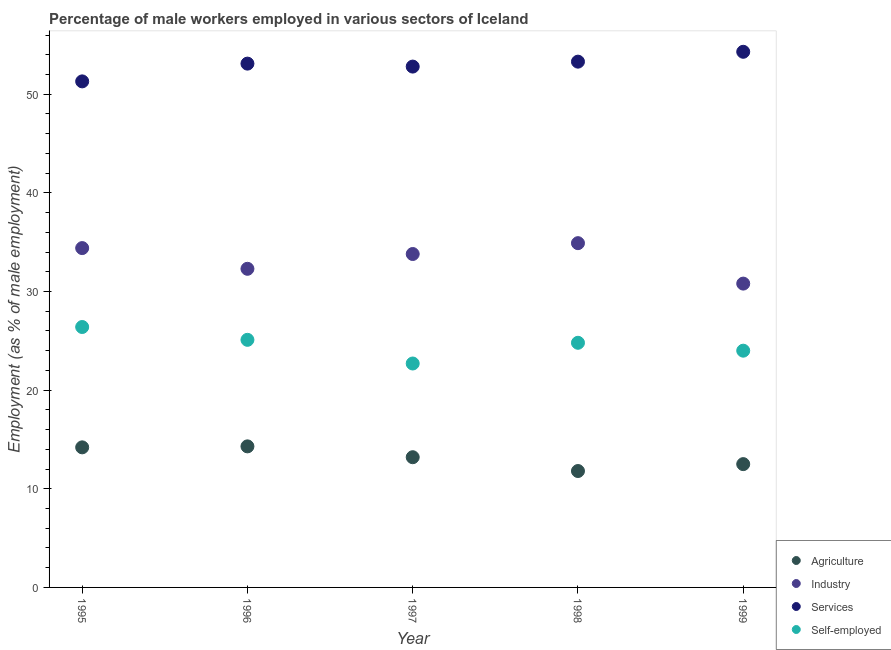How many different coloured dotlines are there?
Offer a very short reply. 4. Is the number of dotlines equal to the number of legend labels?
Give a very brief answer. Yes. What is the percentage of male workers in services in 1998?
Your answer should be compact. 53.3. Across all years, what is the maximum percentage of self employed male workers?
Offer a terse response. 26.4. Across all years, what is the minimum percentage of male workers in industry?
Provide a short and direct response. 30.8. In which year was the percentage of male workers in industry maximum?
Provide a succinct answer. 1998. What is the total percentage of self employed male workers in the graph?
Offer a very short reply. 123. What is the difference between the percentage of male workers in industry in 1995 and that in 1997?
Your answer should be compact. 0.6. What is the difference between the percentage of self employed male workers in 1999 and the percentage of male workers in agriculture in 1996?
Ensure brevity in your answer.  9.7. What is the average percentage of male workers in agriculture per year?
Offer a terse response. 13.2. In the year 1998, what is the difference between the percentage of self employed male workers and percentage of male workers in services?
Give a very brief answer. -28.5. In how many years, is the percentage of male workers in services greater than 44 %?
Your response must be concise. 5. What is the ratio of the percentage of male workers in services in 1995 to that in 1997?
Provide a short and direct response. 0.97. Is the percentage of self employed male workers in 1995 less than that in 1998?
Offer a terse response. No. What is the difference between the highest and the second highest percentage of male workers in services?
Keep it short and to the point. 1. What is the difference between the highest and the lowest percentage of male workers in industry?
Provide a succinct answer. 4.1. Is it the case that in every year, the sum of the percentage of male workers in agriculture and percentage of male workers in industry is greater than the percentage of male workers in services?
Ensure brevity in your answer.  No. Does the percentage of self employed male workers monotonically increase over the years?
Your answer should be compact. No. Is the percentage of male workers in services strictly less than the percentage of self employed male workers over the years?
Offer a very short reply. No. Does the graph contain any zero values?
Offer a terse response. No. Does the graph contain grids?
Keep it short and to the point. No. Where does the legend appear in the graph?
Ensure brevity in your answer.  Bottom right. How are the legend labels stacked?
Provide a succinct answer. Vertical. What is the title of the graph?
Give a very brief answer. Percentage of male workers employed in various sectors of Iceland. What is the label or title of the Y-axis?
Your answer should be very brief. Employment (as % of male employment). What is the Employment (as % of male employment) of Agriculture in 1995?
Offer a terse response. 14.2. What is the Employment (as % of male employment) of Industry in 1995?
Provide a succinct answer. 34.4. What is the Employment (as % of male employment) in Services in 1995?
Keep it short and to the point. 51.3. What is the Employment (as % of male employment) in Self-employed in 1995?
Offer a very short reply. 26.4. What is the Employment (as % of male employment) of Agriculture in 1996?
Your response must be concise. 14.3. What is the Employment (as % of male employment) in Industry in 1996?
Offer a terse response. 32.3. What is the Employment (as % of male employment) of Services in 1996?
Give a very brief answer. 53.1. What is the Employment (as % of male employment) in Self-employed in 1996?
Ensure brevity in your answer.  25.1. What is the Employment (as % of male employment) in Agriculture in 1997?
Make the answer very short. 13.2. What is the Employment (as % of male employment) in Industry in 1997?
Your answer should be very brief. 33.8. What is the Employment (as % of male employment) in Services in 1997?
Your response must be concise. 52.8. What is the Employment (as % of male employment) in Self-employed in 1997?
Offer a very short reply. 22.7. What is the Employment (as % of male employment) in Agriculture in 1998?
Provide a succinct answer. 11.8. What is the Employment (as % of male employment) in Industry in 1998?
Provide a succinct answer. 34.9. What is the Employment (as % of male employment) of Services in 1998?
Provide a succinct answer. 53.3. What is the Employment (as % of male employment) in Self-employed in 1998?
Keep it short and to the point. 24.8. What is the Employment (as % of male employment) in Agriculture in 1999?
Offer a very short reply. 12.5. What is the Employment (as % of male employment) of Industry in 1999?
Your answer should be compact. 30.8. What is the Employment (as % of male employment) in Services in 1999?
Keep it short and to the point. 54.3. Across all years, what is the maximum Employment (as % of male employment) of Agriculture?
Offer a terse response. 14.3. Across all years, what is the maximum Employment (as % of male employment) in Industry?
Make the answer very short. 34.9. Across all years, what is the maximum Employment (as % of male employment) in Services?
Keep it short and to the point. 54.3. Across all years, what is the maximum Employment (as % of male employment) in Self-employed?
Give a very brief answer. 26.4. Across all years, what is the minimum Employment (as % of male employment) of Agriculture?
Your answer should be compact. 11.8. Across all years, what is the minimum Employment (as % of male employment) in Industry?
Provide a succinct answer. 30.8. Across all years, what is the minimum Employment (as % of male employment) in Services?
Ensure brevity in your answer.  51.3. Across all years, what is the minimum Employment (as % of male employment) of Self-employed?
Keep it short and to the point. 22.7. What is the total Employment (as % of male employment) of Agriculture in the graph?
Offer a very short reply. 66. What is the total Employment (as % of male employment) in Industry in the graph?
Keep it short and to the point. 166.2. What is the total Employment (as % of male employment) in Services in the graph?
Your answer should be very brief. 264.8. What is the total Employment (as % of male employment) of Self-employed in the graph?
Your answer should be very brief. 123. What is the difference between the Employment (as % of male employment) in Services in 1995 and that in 1996?
Provide a succinct answer. -1.8. What is the difference between the Employment (as % of male employment) of Services in 1995 and that in 1997?
Provide a short and direct response. -1.5. What is the difference between the Employment (as % of male employment) in Self-employed in 1995 and that in 1997?
Ensure brevity in your answer.  3.7. What is the difference between the Employment (as % of male employment) of Agriculture in 1995 and that in 1999?
Your answer should be very brief. 1.7. What is the difference between the Employment (as % of male employment) of Services in 1995 and that in 1999?
Your answer should be compact. -3. What is the difference between the Employment (as % of male employment) in Self-employed in 1995 and that in 1999?
Your answer should be very brief. 2.4. What is the difference between the Employment (as % of male employment) of Agriculture in 1996 and that in 1997?
Your answer should be very brief. 1.1. What is the difference between the Employment (as % of male employment) in Self-employed in 1996 and that in 1998?
Provide a short and direct response. 0.3. What is the difference between the Employment (as % of male employment) in Services in 1996 and that in 1999?
Offer a terse response. -1.2. What is the difference between the Employment (as % of male employment) in Self-employed in 1996 and that in 1999?
Ensure brevity in your answer.  1.1. What is the difference between the Employment (as % of male employment) of Agriculture in 1997 and that in 1998?
Make the answer very short. 1.4. What is the difference between the Employment (as % of male employment) in Industry in 1997 and that in 1998?
Your answer should be compact. -1.1. What is the difference between the Employment (as % of male employment) in Services in 1997 and that in 1999?
Give a very brief answer. -1.5. What is the difference between the Employment (as % of male employment) in Self-employed in 1997 and that in 1999?
Offer a very short reply. -1.3. What is the difference between the Employment (as % of male employment) in Agriculture in 1998 and that in 1999?
Your response must be concise. -0.7. What is the difference between the Employment (as % of male employment) of Industry in 1998 and that in 1999?
Your answer should be compact. 4.1. What is the difference between the Employment (as % of male employment) in Services in 1998 and that in 1999?
Ensure brevity in your answer.  -1. What is the difference between the Employment (as % of male employment) in Self-employed in 1998 and that in 1999?
Your answer should be compact. 0.8. What is the difference between the Employment (as % of male employment) in Agriculture in 1995 and the Employment (as % of male employment) in Industry in 1996?
Your answer should be very brief. -18.1. What is the difference between the Employment (as % of male employment) of Agriculture in 1995 and the Employment (as % of male employment) of Services in 1996?
Offer a terse response. -38.9. What is the difference between the Employment (as % of male employment) in Industry in 1995 and the Employment (as % of male employment) in Services in 1996?
Provide a succinct answer. -18.7. What is the difference between the Employment (as % of male employment) of Industry in 1995 and the Employment (as % of male employment) of Self-employed in 1996?
Give a very brief answer. 9.3. What is the difference between the Employment (as % of male employment) in Services in 1995 and the Employment (as % of male employment) in Self-employed in 1996?
Provide a short and direct response. 26.2. What is the difference between the Employment (as % of male employment) in Agriculture in 1995 and the Employment (as % of male employment) in Industry in 1997?
Offer a terse response. -19.6. What is the difference between the Employment (as % of male employment) in Agriculture in 1995 and the Employment (as % of male employment) in Services in 1997?
Make the answer very short. -38.6. What is the difference between the Employment (as % of male employment) of Industry in 1995 and the Employment (as % of male employment) of Services in 1997?
Offer a very short reply. -18.4. What is the difference between the Employment (as % of male employment) of Industry in 1995 and the Employment (as % of male employment) of Self-employed in 1997?
Your response must be concise. 11.7. What is the difference between the Employment (as % of male employment) in Services in 1995 and the Employment (as % of male employment) in Self-employed in 1997?
Offer a terse response. 28.6. What is the difference between the Employment (as % of male employment) of Agriculture in 1995 and the Employment (as % of male employment) of Industry in 1998?
Your answer should be very brief. -20.7. What is the difference between the Employment (as % of male employment) of Agriculture in 1995 and the Employment (as % of male employment) of Services in 1998?
Keep it short and to the point. -39.1. What is the difference between the Employment (as % of male employment) in Industry in 1995 and the Employment (as % of male employment) in Services in 1998?
Provide a succinct answer. -18.9. What is the difference between the Employment (as % of male employment) of Services in 1995 and the Employment (as % of male employment) of Self-employed in 1998?
Keep it short and to the point. 26.5. What is the difference between the Employment (as % of male employment) of Agriculture in 1995 and the Employment (as % of male employment) of Industry in 1999?
Provide a short and direct response. -16.6. What is the difference between the Employment (as % of male employment) in Agriculture in 1995 and the Employment (as % of male employment) in Services in 1999?
Offer a very short reply. -40.1. What is the difference between the Employment (as % of male employment) in Agriculture in 1995 and the Employment (as % of male employment) in Self-employed in 1999?
Your answer should be very brief. -9.8. What is the difference between the Employment (as % of male employment) of Industry in 1995 and the Employment (as % of male employment) of Services in 1999?
Give a very brief answer. -19.9. What is the difference between the Employment (as % of male employment) of Services in 1995 and the Employment (as % of male employment) of Self-employed in 1999?
Ensure brevity in your answer.  27.3. What is the difference between the Employment (as % of male employment) of Agriculture in 1996 and the Employment (as % of male employment) of Industry in 1997?
Provide a short and direct response. -19.5. What is the difference between the Employment (as % of male employment) in Agriculture in 1996 and the Employment (as % of male employment) in Services in 1997?
Your response must be concise. -38.5. What is the difference between the Employment (as % of male employment) in Industry in 1996 and the Employment (as % of male employment) in Services in 1997?
Keep it short and to the point. -20.5. What is the difference between the Employment (as % of male employment) in Industry in 1996 and the Employment (as % of male employment) in Self-employed in 1997?
Your response must be concise. 9.6. What is the difference between the Employment (as % of male employment) in Services in 1996 and the Employment (as % of male employment) in Self-employed in 1997?
Make the answer very short. 30.4. What is the difference between the Employment (as % of male employment) in Agriculture in 1996 and the Employment (as % of male employment) in Industry in 1998?
Your answer should be very brief. -20.6. What is the difference between the Employment (as % of male employment) of Agriculture in 1996 and the Employment (as % of male employment) of Services in 1998?
Give a very brief answer. -39. What is the difference between the Employment (as % of male employment) of Services in 1996 and the Employment (as % of male employment) of Self-employed in 1998?
Offer a terse response. 28.3. What is the difference between the Employment (as % of male employment) in Agriculture in 1996 and the Employment (as % of male employment) in Industry in 1999?
Your response must be concise. -16.5. What is the difference between the Employment (as % of male employment) in Agriculture in 1996 and the Employment (as % of male employment) in Self-employed in 1999?
Make the answer very short. -9.7. What is the difference between the Employment (as % of male employment) in Industry in 1996 and the Employment (as % of male employment) in Services in 1999?
Your answer should be compact. -22. What is the difference between the Employment (as % of male employment) of Services in 1996 and the Employment (as % of male employment) of Self-employed in 1999?
Give a very brief answer. 29.1. What is the difference between the Employment (as % of male employment) in Agriculture in 1997 and the Employment (as % of male employment) in Industry in 1998?
Give a very brief answer. -21.7. What is the difference between the Employment (as % of male employment) of Agriculture in 1997 and the Employment (as % of male employment) of Services in 1998?
Provide a short and direct response. -40.1. What is the difference between the Employment (as % of male employment) of Industry in 1997 and the Employment (as % of male employment) of Services in 1998?
Keep it short and to the point. -19.5. What is the difference between the Employment (as % of male employment) of Industry in 1997 and the Employment (as % of male employment) of Self-employed in 1998?
Provide a succinct answer. 9. What is the difference between the Employment (as % of male employment) of Services in 1997 and the Employment (as % of male employment) of Self-employed in 1998?
Offer a terse response. 28. What is the difference between the Employment (as % of male employment) of Agriculture in 1997 and the Employment (as % of male employment) of Industry in 1999?
Give a very brief answer. -17.6. What is the difference between the Employment (as % of male employment) in Agriculture in 1997 and the Employment (as % of male employment) in Services in 1999?
Ensure brevity in your answer.  -41.1. What is the difference between the Employment (as % of male employment) in Agriculture in 1997 and the Employment (as % of male employment) in Self-employed in 1999?
Your response must be concise. -10.8. What is the difference between the Employment (as % of male employment) of Industry in 1997 and the Employment (as % of male employment) of Services in 1999?
Provide a succinct answer. -20.5. What is the difference between the Employment (as % of male employment) in Industry in 1997 and the Employment (as % of male employment) in Self-employed in 1999?
Give a very brief answer. 9.8. What is the difference between the Employment (as % of male employment) of Services in 1997 and the Employment (as % of male employment) of Self-employed in 1999?
Provide a succinct answer. 28.8. What is the difference between the Employment (as % of male employment) in Agriculture in 1998 and the Employment (as % of male employment) in Industry in 1999?
Give a very brief answer. -19. What is the difference between the Employment (as % of male employment) of Agriculture in 1998 and the Employment (as % of male employment) of Services in 1999?
Provide a succinct answer. -42.5. What is the difference between the Employment (as % of male employment) in Agriculture in 1998 and the Employment (as % of male employment) in Self-employed in 1999?
Your response must be concise. -12.2. What is the difference between the Employment (as % of male employment) in Industry in 1998 and the Employment (as % of male employment) in Services in 1999?
Keep it short and to the point. -19.4. What is the difference between the Employment (as % of male employment) in Industry in 1998 and the Employment (as % of male employment) in Self-employed in 1999?
Your answer should be compact. 10.9. What is the difference between the Employment (as % of male employment) of Services in 1998 and the Employment (as % of male employment) of Self-employed in 1999?
Offer a very short reply. 29.3. What is the average Employment (as % of male employment) of Agriculture per year?
Keep it short and to the point. 13.2. What is the average Employment (as % of male employment) in Industry per year?
Give a very brief answer. 33.24. What is the average Employment (as % of male employment) in Services per year?
Offer a terse response. 52.96. What is the average Employment (as % of male employment) in Self-employed per year?
Offer a terse response. 24.6. In the year 1995, what is the difference between the Employment (as % of male employment) of Agriculture and Employment (as % of male employment) of Industry?
Provide a succinct answer. -20.2. In the year 1995, what is the difference between the Employment (as % of male employment) of Agriculture and Employment (as % of male employment) of Services?
Provide a short and direct response. -37.1. In the year 1995, what is the difference between the Employment (as % of male employment) in Agriculture and Employment (as % of male employment) in Self-employed?
Your answer should be compact. -12.2. In the year 1995, what is the difference between the Employment (as % of male employment) of Industry and Employment (as % of male employment) of Services?
Ensure brevity in your answer.  -16.9. In the year 1995, what is the difference between the Employment (as % of male employment) in Industry and Employment (as % of male employment) in Self-employed?
Your response must be concise. 8. In the year 1995, what is the difference between the Employment (as % of male employment) in Services and Employment (as % of male employment) in Self-employed?
Provide a succinct answer. 24.9. In the year 1996, what is the difference between the Employment (as % of male employment) in Agriculture and Employment (as % of male employment) in Services?
Ensure brevity in your answer.  -38.8. In the year 1996, what is the difference between the Employment (as % of male employment) of Industry and Employment (as % of male employment) of Services?
Make the answer very short. -20.8. In the year 1996, what is the difference between the Employment (as % of male employment) in Industry and Employment (as % of male employment) in Self-employed?
Keep it short and to the point. 7.2. In the year 1996, what is the difference between the Employment (as % of male employment) of Services and Employment (as % of male employment) of Self-employed?
Your answer should be compact. 28. In the year 1997, what is the difference between the Employment (as % of male employment) in Agriculture and Employment (as % of male employment) in Industry?
Offer a terse response. -20.6. In the year 1997, what is the difference between the Employment (as % of male employment) of Agriculture and Employment (as % of male employment) of Services?
Offer a terse response. -39.6. In the year 1997, what is the difference between the Employment (as % of male employment) in Agriculture and Employment (as % of male employment) in Self-employed?
Give a very brief answer. -9.5. In the year 1997, what is the difference between the Employment (as % of male employment) of Industry and Employment (as % of male employment) of Services?
Your answer should be very brief. -19. In the year 1997, what is the difference between the Employment (as % of male employment) in Industry and Employment (as % of male employment) in Self-employed?
Your answer should be compact. 11.1. In the year 1997, what is the difference between the Employment (as % of male employment) in Services and Employment (as % of male employment) in Self-employed?
Keep it short and to the point. 30.1. In the year 1998, what is the difference between the Employment (as % of male employment) in Agriculture and Employment (as % of male employment) in Industry?
Give a very brief answer. -23.1. In the year 1998, what is the difference between the Employment (as % of male employment) of Agriculture and Employment (as % of male employment) of Services?
Make the answer very short. -41.5. In the year 1998, what is the difference between the Employment (as % of male employment) of Industry and Employment (as % of male employment) of Services?
Offer a terse response. -18.4. In the year 1998, what is the difference between the Employment (as % of male employment) of Industry and Employment (as % of male employment) of Self-employed?
Provide a short and direct response. 10.1. In the year 1998, what is the difference between the Employment (as % of male employment) of Services and Employment (as % of male employment) of Self-employed?
Offer a very short reply. 28.5. In the year 1999, what is the difference between the Employment (as % of male employment) in Agriculture and Employment (as % of male employment) in Industry?
Offer a terse response. -18.3. In the year 1999, what is the difference between the Employment (as % of male employment) of Agriculture and Employment (as % of male employment) of Services?
Ensure brevity in your answer.  -41.8. In the year 1999, what is the difference between the Employment (as % of male employment) in Industry and Employment (as % of male employment) in Services?
Make the answer very short. -23.5. In the year 1999, what is the difference between the Employment (as % of male employment) in Services and Employment (as % of male employment) in Self-employed?
Provide a short and direct response. 30.3. What is the ratio of the Employment (as % of male employment) of Agriculture in 1995 to that in 1996?
Your response must be concise. 0.99. What is the ratio of the Employment (as % of male employment) in Industry in 1995 to that in 1996?
Offer a very short reply. 1.06. What is the ratio of the Employment (as % of male employment) of Services in 1995 to that in 1996?
Your answer should be compact. 0.97. What is the ratio of the Employment (as % of male employment) in Self-employed in 1995 to that in 1996?
Ensure brevity in your answer.  1.05. What is the ratio of the Employment (as % of male employment) in Agriculture in 1995 to that in 1997?
Keep it short and to the point. 1.08. What is the ratio of the Employment (as % of male employment) in Industry in 1995 to that in 1997?
Give a very brief answer. 1.02. What is the ratio of the Employment (as % of male employment) in Services in 1995 to that in 1997?
Your answer should be compact. 0.97. What is the ratio of the Employment (as % of male employment) of Self-employed in 1995 to that in 1997?
Make the answer very short. 1.16. What is the ratio of the Employment (as % of male employment) in Agriculture in 1995 to that in 1998?
Your answer should be very brief. 1.2. What is the ratio of the Employment (as % of male employment) of Industry in 1995 to that in 1998?
Ensure brevity in your answer.  0.99. What is the ratio of the Employment (as % of male employment) in Services in 1995 to that in 1998?
Offer a terse response. 0.96. What is the ratio of the Employment (as % of male employment) in Self-employed in 1995 to that in 1998?
Offer a very short reply. 1.06. What is the ratio of the Employment (as % of male employment) of Agriculture in 1995 to that in 1999?
Offer a very short reply. 1.14. What is the ratio of the Employment (as % of male employment) of Industry in 1995 to that in 1999?
Provide a short and direct response. 1.12. What is the ratio of the Employment (as % of male employment) of Services in 1995 to that in 1999?
Offer a terse response. 0.94. What is the ratio of the Employment (as % of male employment) in Self-employed in 1995 to that in 1999?
Your response must be concise. 1.1. What is the ratio of the Employment (as % of male employment) of Agriculture in 1996 to that in 1997?
Provide a short and direct response. 1.08. What is the ratio of the Employment (as % of male employment) of Industry in 1996 to that in 1997?
Your answer should be very brief. 0.96. What is the ratio of the Employment (as % of male employment) in Self-employed in 1996 to that in 1997?
Offer a very short reply. 1.11. What is the ratio of the Employment (as % of male employment) in Agriculture in 1996 to that in 1998?
Give a very brief answer. 1.21. What is the ratio of the Employment (as % of male employment) of Industry in 1996 to that in 1998?
Your answer should be compact. 0.93. What is the ratio of the Employment (as % of male employment) in Self-employed in 1996 to that in 1998?
Ensure brevity in your answer.  1.01. What is the ratio of the Employment (as % of male employment) in Agriculture in 1996 to that in 1999?
Offer a terse response. 1.14. What is the ratio of the Employment (as % of male employment) in Industry in 1996 to that in 1999?
Keep it short and to the point. 1.05. What is the ratio of the Employment (as % of male employment) of Services in 1996 to that in 1999?
Make the answer very short. 0.98. What is the ratio of the Employment (as % of male employment) of Self-employed in 1996 to that in 1999?
Make the answer very short. 1.05. What is the ratio of the Employment (as % of male employment) in Agriculture in 1997 to that in 1998?
Offer a very short reply. 1.12. What is the ratio of the Employment (as % of male employment) in Industry in 1997 to that in 1998?
Provide a short and direct response. 0.97. What is the ratio of the Employment (as % of male employment) in Services in 1997 to that in 1998?
Ensure brevity in your answer.  0.99. What is the ratio of the Employment (as % of male employment) in Self-employed in 1997 to that in 1998?
Provide a short and direct response. 0.92. What is the ratio of the Employment (as % of male employment) of Agriculture in 1997 to that in 1999?
Your answer should be compact. 1.06. What is the ratio of the Employment (as % of male employment) of Industry in 1997 to that in 1999?
Your answer should be very brief. 1.1. What is the ratio of the Employment (as % of male employment) of Services in 1997 to that in 1999?
Offer a very short reply. 0.97. What is the ratio of the Employment (as % of male employment) of Self-employed in 1997 to that in 1999?
Offer a very short reply. 0.95. What is the ratio of the Employment (as % of male employment) of Agriculture in 1998 to that in 1999?
Your answer should be compact. 0.94. What is the ratio of the Employment (as % of male employment) of Industry in 1998 to that in 1999?
Provide a succinct answer. 1.13. What is the ratio of the Employment (as % of male employment) in Services in 1998 to that in 1999?
Your response must be concise. 0.98. What is the ratio of the Employment (as % of male employment) in Self-employed in 1998 to that in 1999?
Your response must be concise. 1.03. What is the difference between the highest and the second highest Employment (as % of male employment) in Industry?
Give a very brief answer. 0.5. What is the difference between the highest and the second highest Employment (as % of male employment) in Self-employed?
Keep it short and to the point. 1.3. What is the difference between the highest and the lowest Employment (as % of male employment) in Self-employed?
Keep it short and to the point. 3.7. 